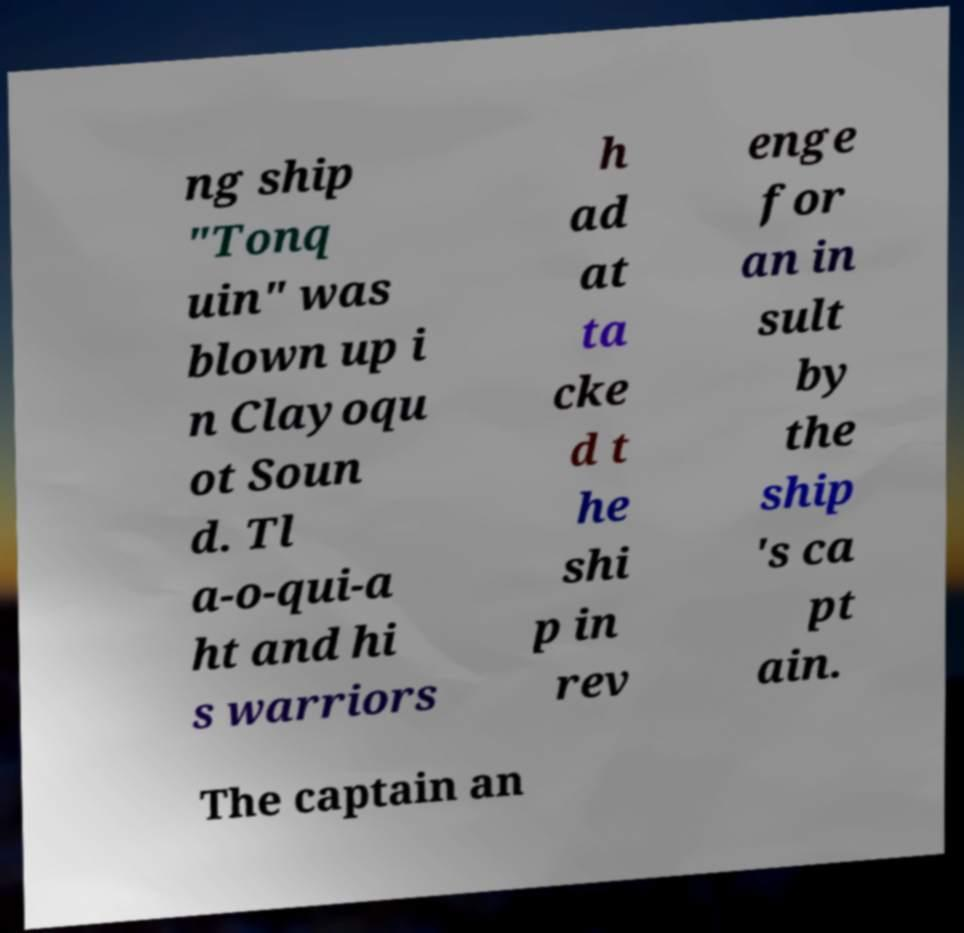Please read and relay the text visible in this image. What does it say? ng ship "Tonq uin" was blown up i n Clayoqu ot Soun d. Tl a-o-qui-a ht and hi s warriors h ad at ta cke d t he shi p in rev enge for an in sult by the ship 's ca pt ain. The captain an 